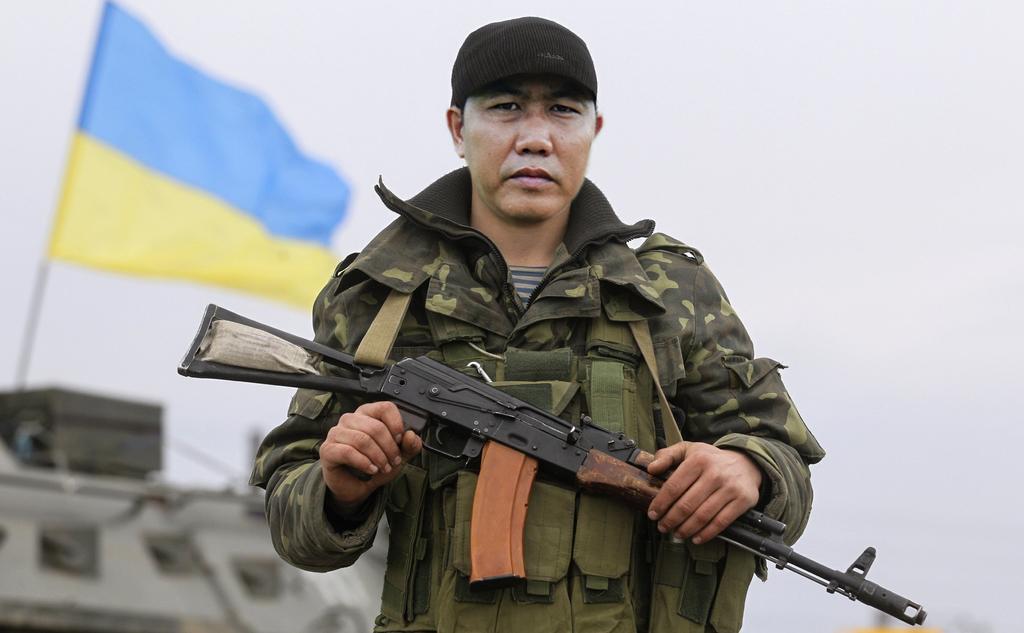How would you summarize this image in a sentence or two? In the center of the image we can see person standing and holding a gun. In the background we can see flag, war tanker and sky. 